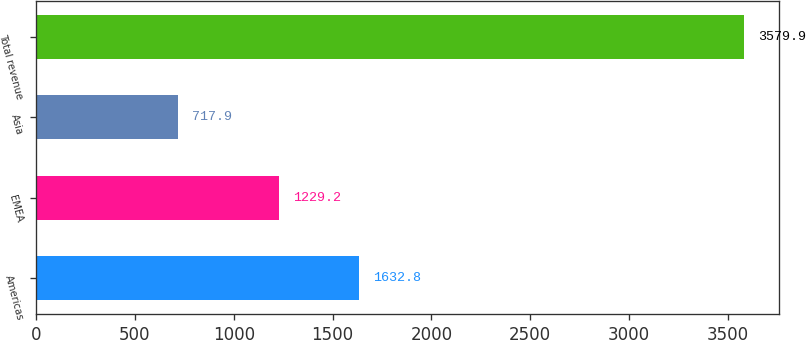<chart> <loc_0><loc_0><loc_500><loc_500><bar_chart><fcel>Americas<fcel>EMEA<fcel>Asia<fcel>Total revenue<nl><fcel>1632.8<fcel>1229.2<fcel>717.9<fcel>3579.9<nl></chart> 